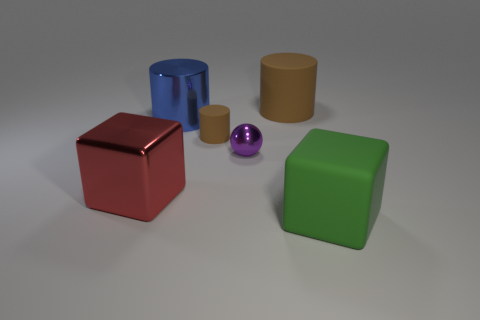What is the texture of the objects in the image? The objects in the image have varying textures that are implied by their visual appearance. The green and red cubes have a matte finish, the blue cylinder looks slightly less matte, the brown cylinder appears to have a surface similar to cardboard, and the small purple ball has a high gloss that suggests a smooth and reflective surface. 